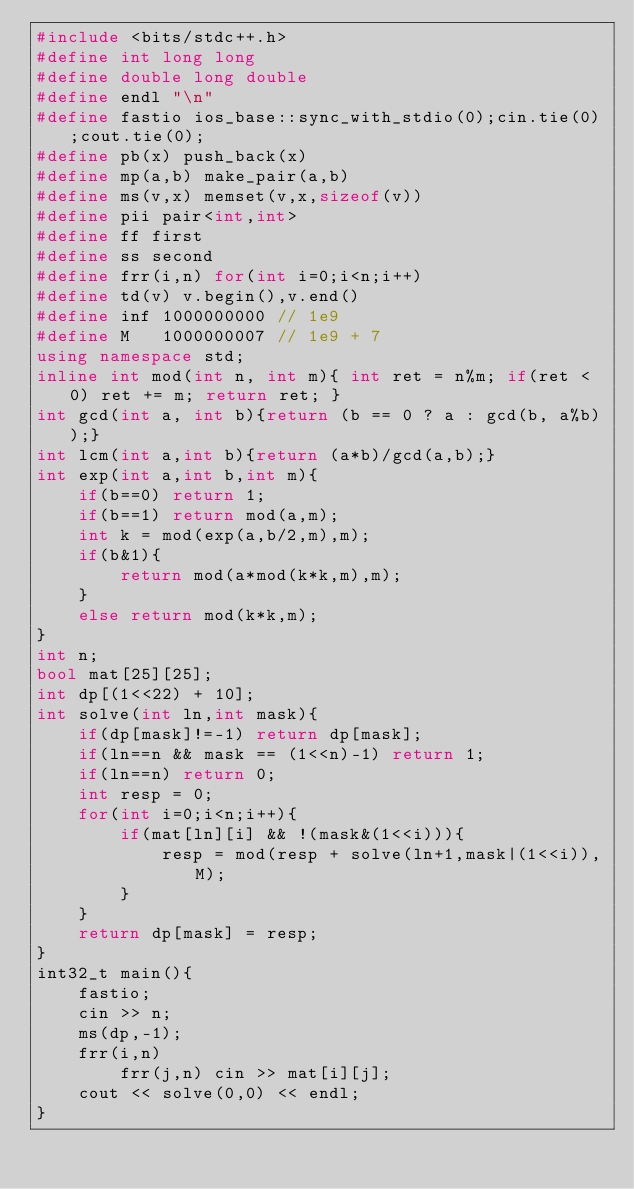Convert code to text. <code><loc_0><loc_0><loc_500><loc_500><_C++_>#include <bits/stdc++.h>
#define int long long
#define double long double
#define endl "\n"
#define fastio ios_base::sync_with_stdio(0);cin.tie(0);cout.tie(0);
#define pb(x) push_back(x)
#define mp(a,b) make_pair(a,b)
#define ms(v,x) memset(v,x,sizeof(v))
#define pii pair<int,int>
#define ff first
#define ss second
#define frr(i,n) for(int i=0;i<n;i++)
#define td(v) v.begin(),v.end()
#define inf 1000000000 // 1e9
#define M   1000000007 // 1e9 + 7
using namespace std;
inline int mod(int n, int m){ int ret = n%m; if(ret < 0) ret += m; return ret; }
int gcd(int a, int b){return (b == 0 ? a : gcd(b, a%b));}
int lcm(int a,int b){return (a*b)/gcd(a,b);}
int exp(int a,int b,int m){
    if(b==0) return 1;
    if(b==1) return mod(a,m);
    int k = mod(exp(a,b/2,m),m);
    if(b&1){
        return mod(a*mod(k*k,m),m);
    }
    else return mod(k*k,m);
}
int n;
bool mat[25][25];
int dp[(1<<22) + 10];
int solve(int ln,int mask){
    if(dp[mask]!=-1) return dp[mask];
    if(ln==n && mask == (1<<n)-1) return 1;
    if(ln==n) return 0;
    int resp = 0;
    for(int i=0;i<n;i++){
        if(mat[ln][i] && !(mask&(1<<i))){
            resp = mod(resp + solve(ln+1,mask|(1<<i)),M);
        }
    }
    return dp[mask] = resp;
}
int32_t main(){
    fastio;
    cin >> n;
    ms(dp,-1);
    frr(i,n)
        frr(j,n) cin >> mat[i][j];
    cout << solve(0,0) << endl;
}</code> 